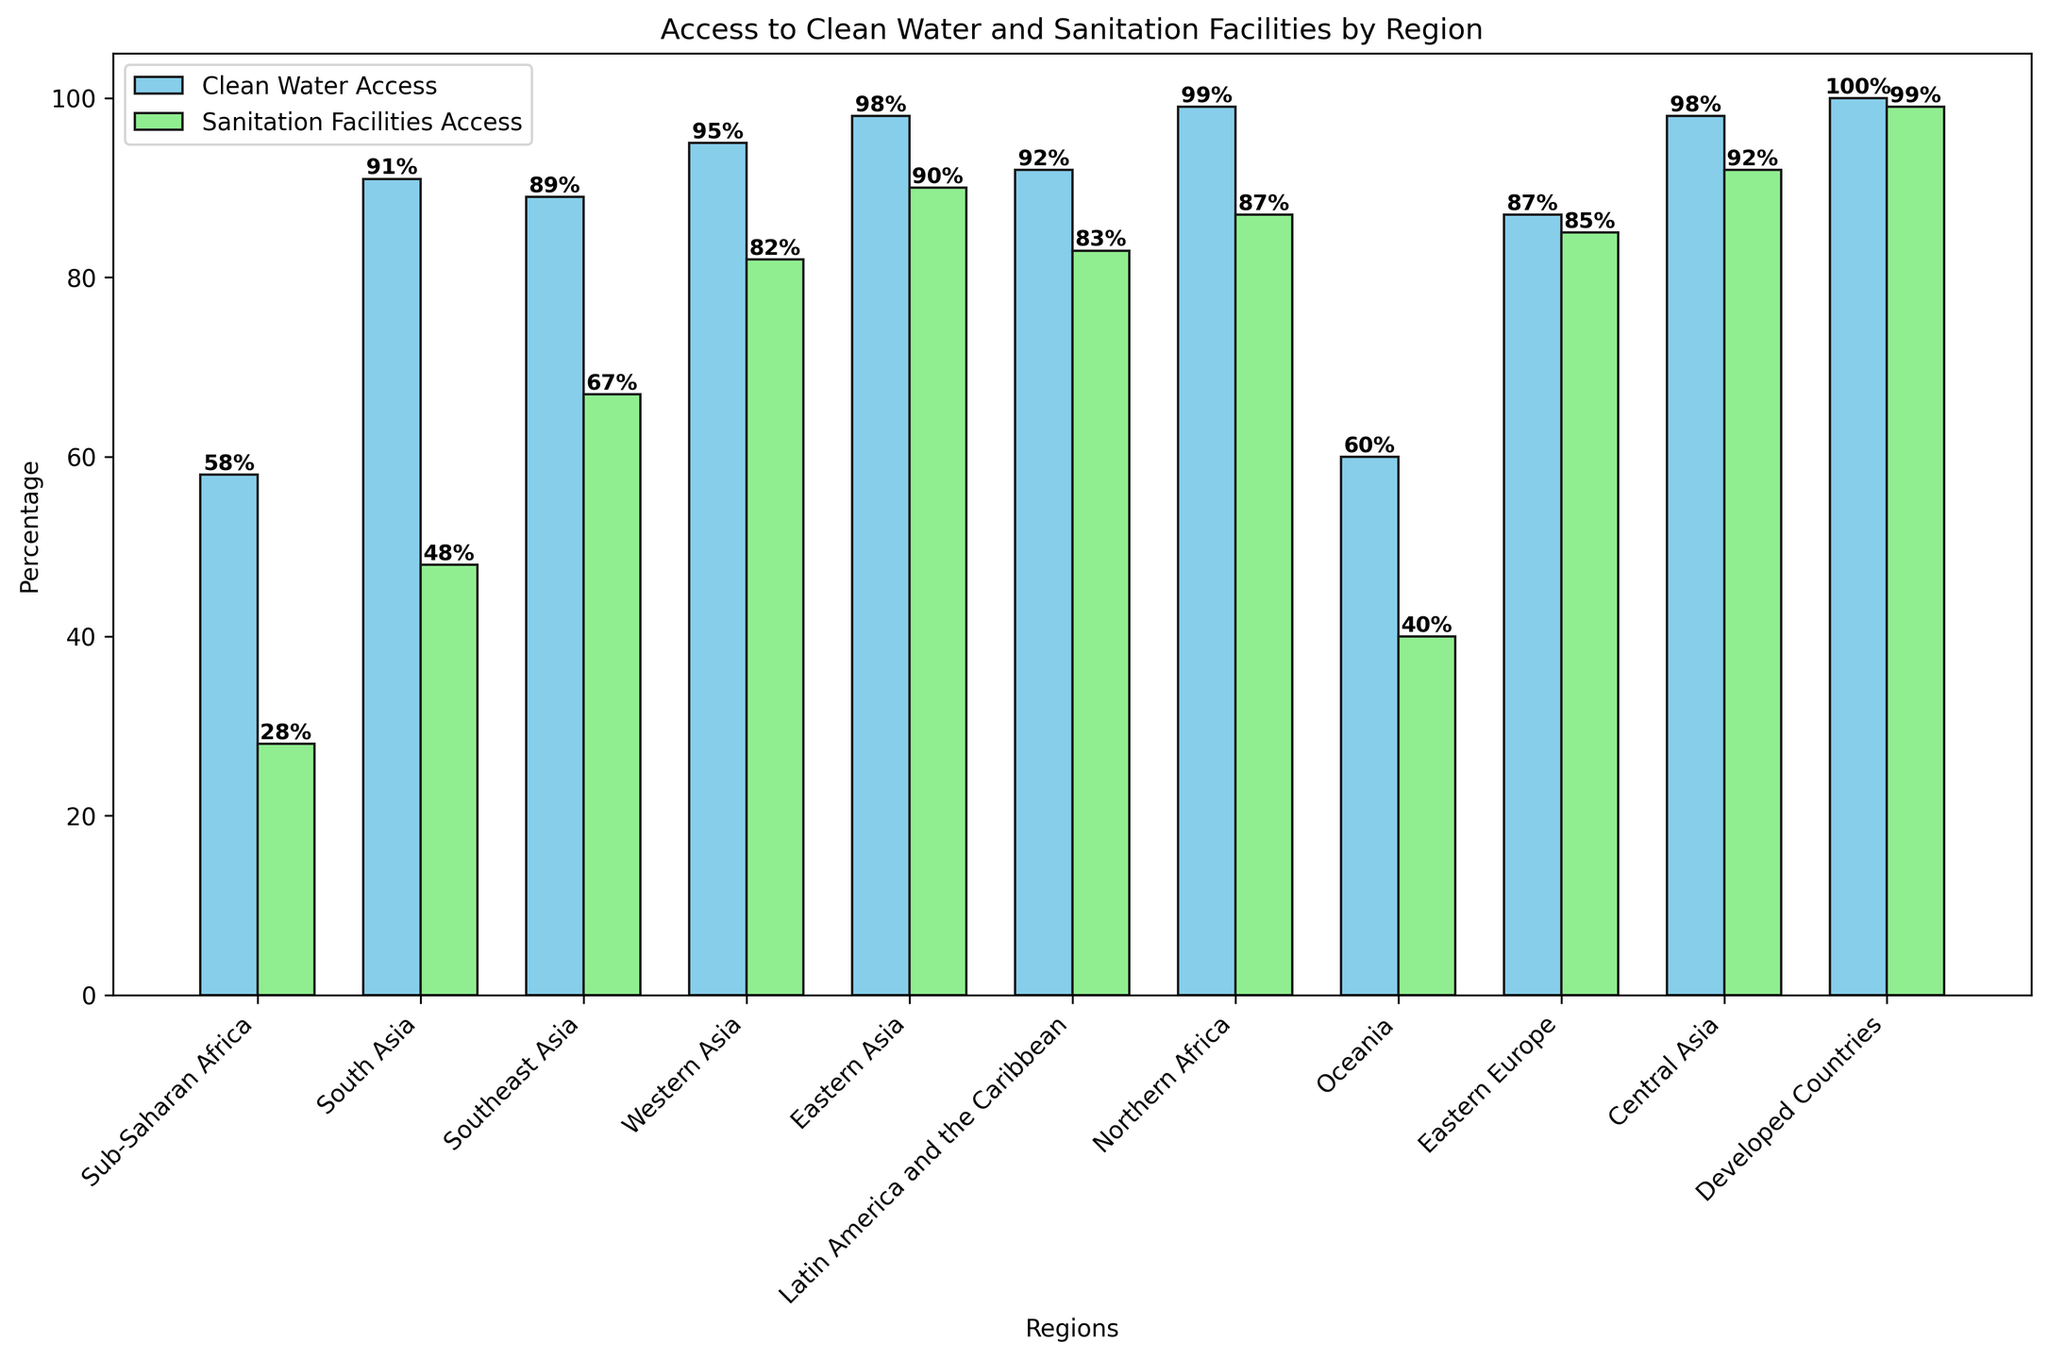Which region has the highest percentage of access to clean water? By looking at the height of the "Clean Water Access" bars, we can see that the bar for "Developed Countries" is the tallest, indicating the highest percentage access to clean water.
Answer: Developed Countries Which region has the lowest percentage of access to sanitation facilities? By looking at the height of the "Sanitation Facilities Access" bars, we can see that the bar for "Sub-Saharan Africa" is the shortest, indicating the lowest percentage access to sanitation facilities.
Answer: Sub-Saharan Africa What is the difference in sanitation facilities access between Latin America and the Caribbean and Western Asia? The access to sanitation facilities percentage for Latin America and the Caribbean is 83%, and for Western Asia, it is 82%. Subtracting 82 from 83 gives a difference of 1%.
Answer: 1% How much higher is the clean water access percentage in Northern Africa compared to Oceania? The clean water access percentage in Northern Africa is 99%, and in Oceania, it is 60%. Subtracting 60 from 99 gives a difference of 39%.
Answer: 39% Which region has a larger gap between access to clean water and sanitation facilities: Southeast Asia or South Asia? For Southeast Asia, the gap is 89% - 67% = 22%. For South Asia, the gap is 91% - 48% = 43%. So, South Asia has a larger gap.
Answer: South Asia What is the combined average percentage of access to clean water and sanitation facilities for Eastern Europe? The percentages for Eastern Europe are 87% for clean water and 85% for sanitation. The average is calculated as (87 + 85) / 2 = 86%.
Answer: 86% Which region has access to clean water closest to 90%? By examining the "Clean Water Access" bars, Southeast Asia has 89%, which is closest to 90%.
Answer: Southeast Asia Is there any region where the percentage of access to sanitation facilities is greater than 85% but less than 90%? By examining the "Sanitation Facilities Access" bars, Eastern Europe and Northern Africa have percentages in this range (85% and 87%, respectively).
Answer: Yes How much more is the access to clean water in Central Asia compared to Sub-Saharan Africa? Central Asia has clean water access at 98%, while Sub-Saharan Africa has 58%. The difference is 98 - 58 = 40%.
Answer: 40% Is the percentage of access to clean water higher or lower than access to sanitation facilities in Western Asia? In Western Asia, access to clean water is 95%, and access to sanitation facilities is 82%. Since 95% is greater than 82%, access to clean water is higher.
Answer: Higher 